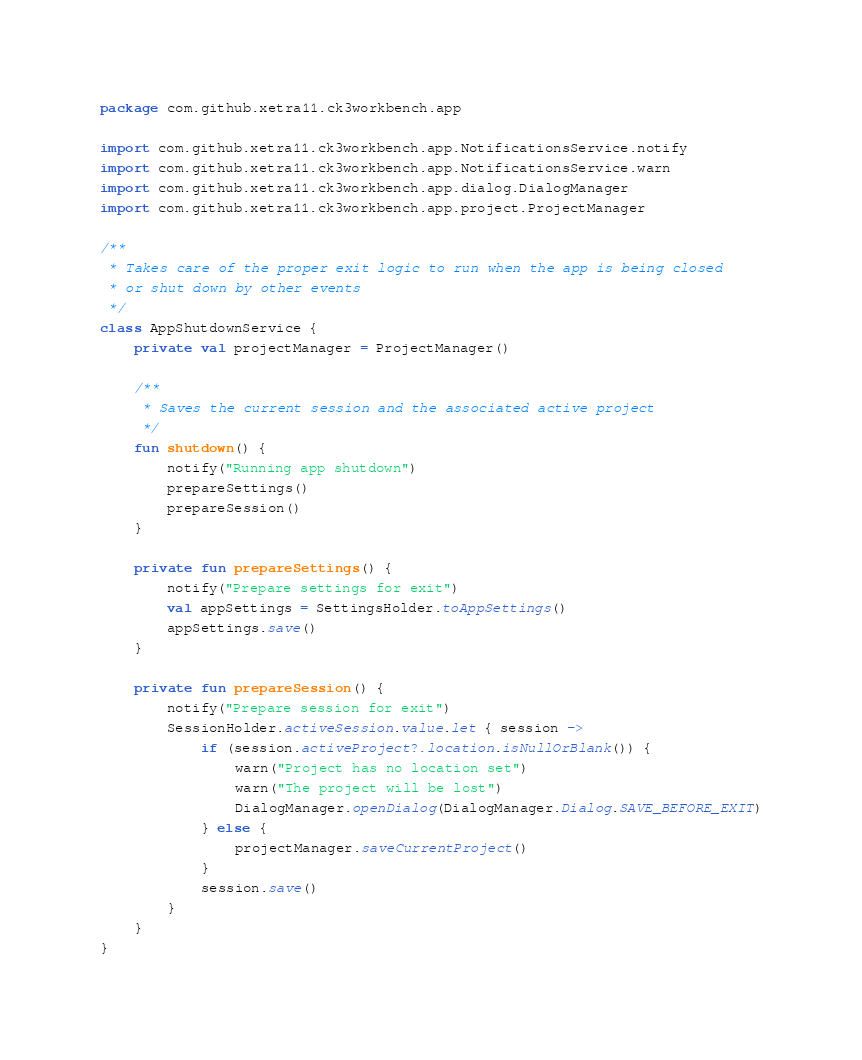Convert code to text. <code><loc_0><loc_0><loc_500><loc_500><_Kotlin_>package com.github.xetra11.ck3workbench.app

import com.github.xetra11.ck3workbench.app.NotificationsService.notify
import com.github.xetra11.ck3workbench.app.NotificationsService.warn
import com.github.xetra11.ck3workbench.app.dialog.DialogManager
import com.github.xetra11.ck3workbench.app.project.ProjectManager

/**
 * Takes care of the proper exit logic to run when the app is being closed
 * or shut down by other events
 */
class AppShutdownService {
    private val projectManager = ProjectManager()

    /**
     * Saves the current session and the associated active project
     */
    fun shutdown() {
        notify("Running app shutdown")
        prepareSettings()
        prepareSession()
    }

    private fun prepareSettings() {
        notify("Prepare settings for exit")
        val appSettings = SettingsHolder.toAppSettings()
        appSettings.save()
    }

    private fun prepareSession() {
        notify("Prepare session for exit")
        SessionHolder.activeSession.value.let { session ->
            if (session.activeProject?.location.isNullOrBlank()) {
                warn("Project has no location set")
                warn("The project will be lost")
                DialogManager.openDialog(DialogManager.Dialog.SAVE_BEFORE_EXIT)
            } else {
                projectManager.saveCurrentProject()
            }
            session.save()
        }
    }
}
</code> 